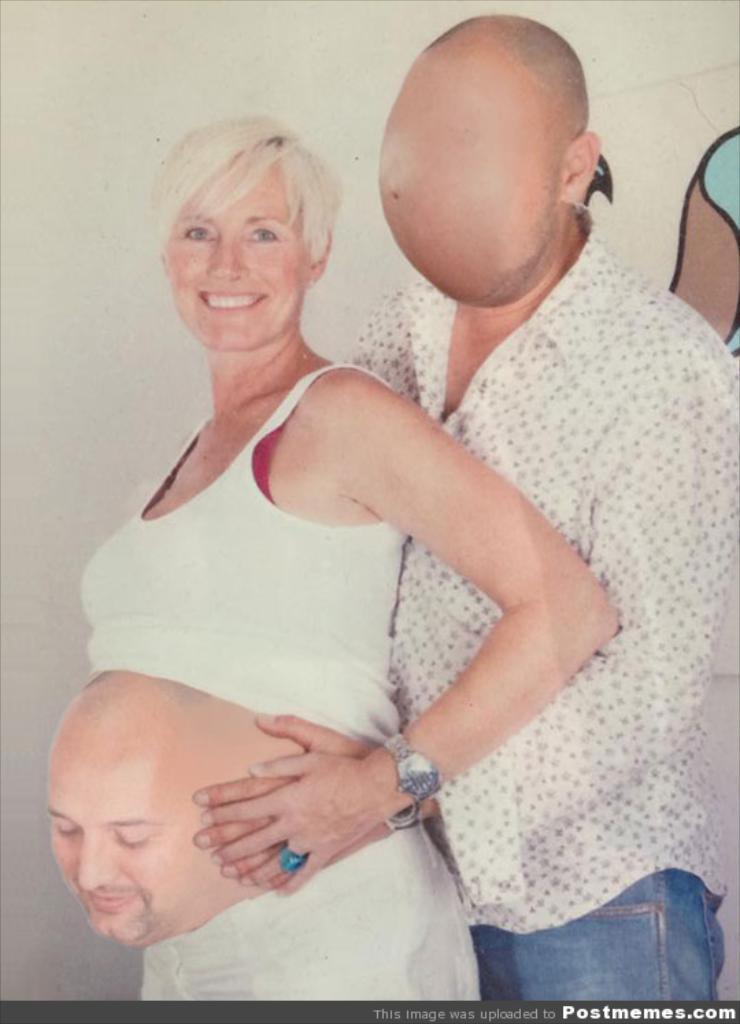Can you describe this image briefly? In this image I can see two persons. the person at right wearing white shirt, blue pant and the person at left wearing white color dress. Background I can see the wall in white. 